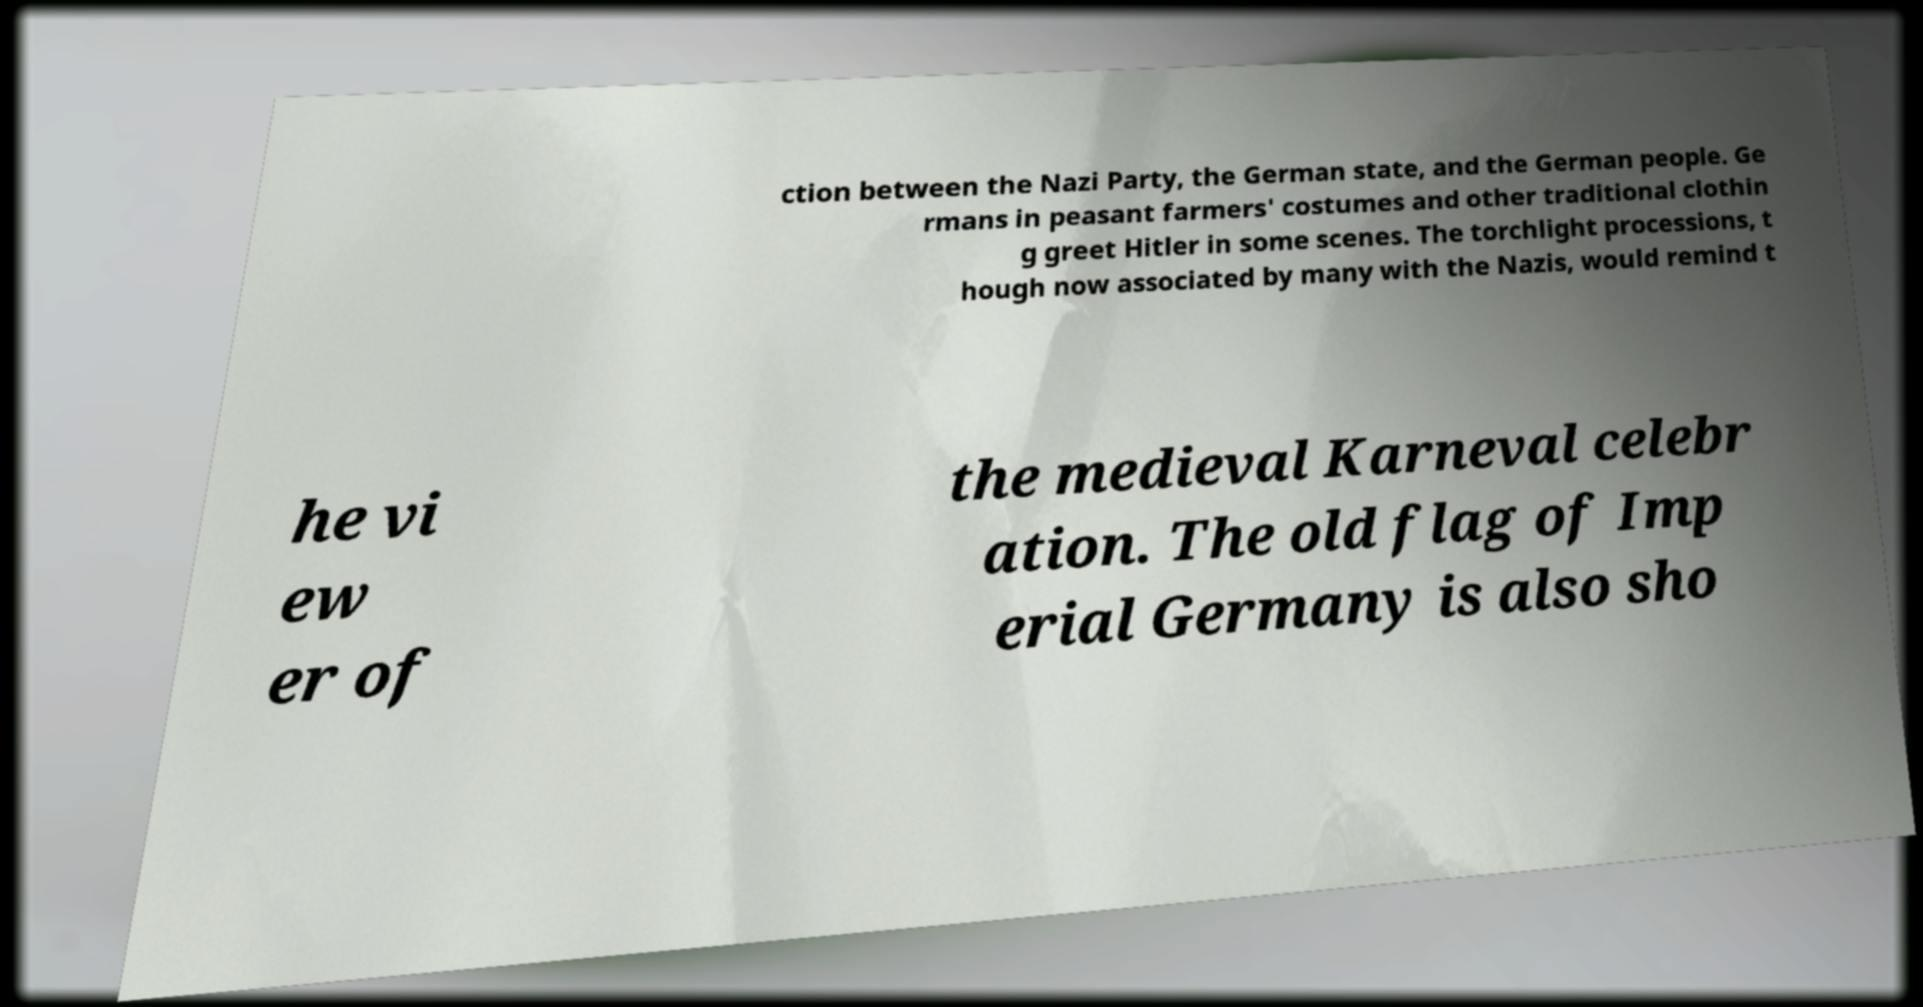For documentation purposes, I need the text within this image transcribed. Could you provide that? ction between the Nazi Party, the German state, and the German people. Ge rmans in peasant farmers' costumes and other traditional clothin g greet Hitler in some scenes. The torchlight processions, t hough now associated by many with the Nazis, would remind t he vi ew er of the medieval Karneval celebr ation. The old flag of Imp erial Germany is also sho 